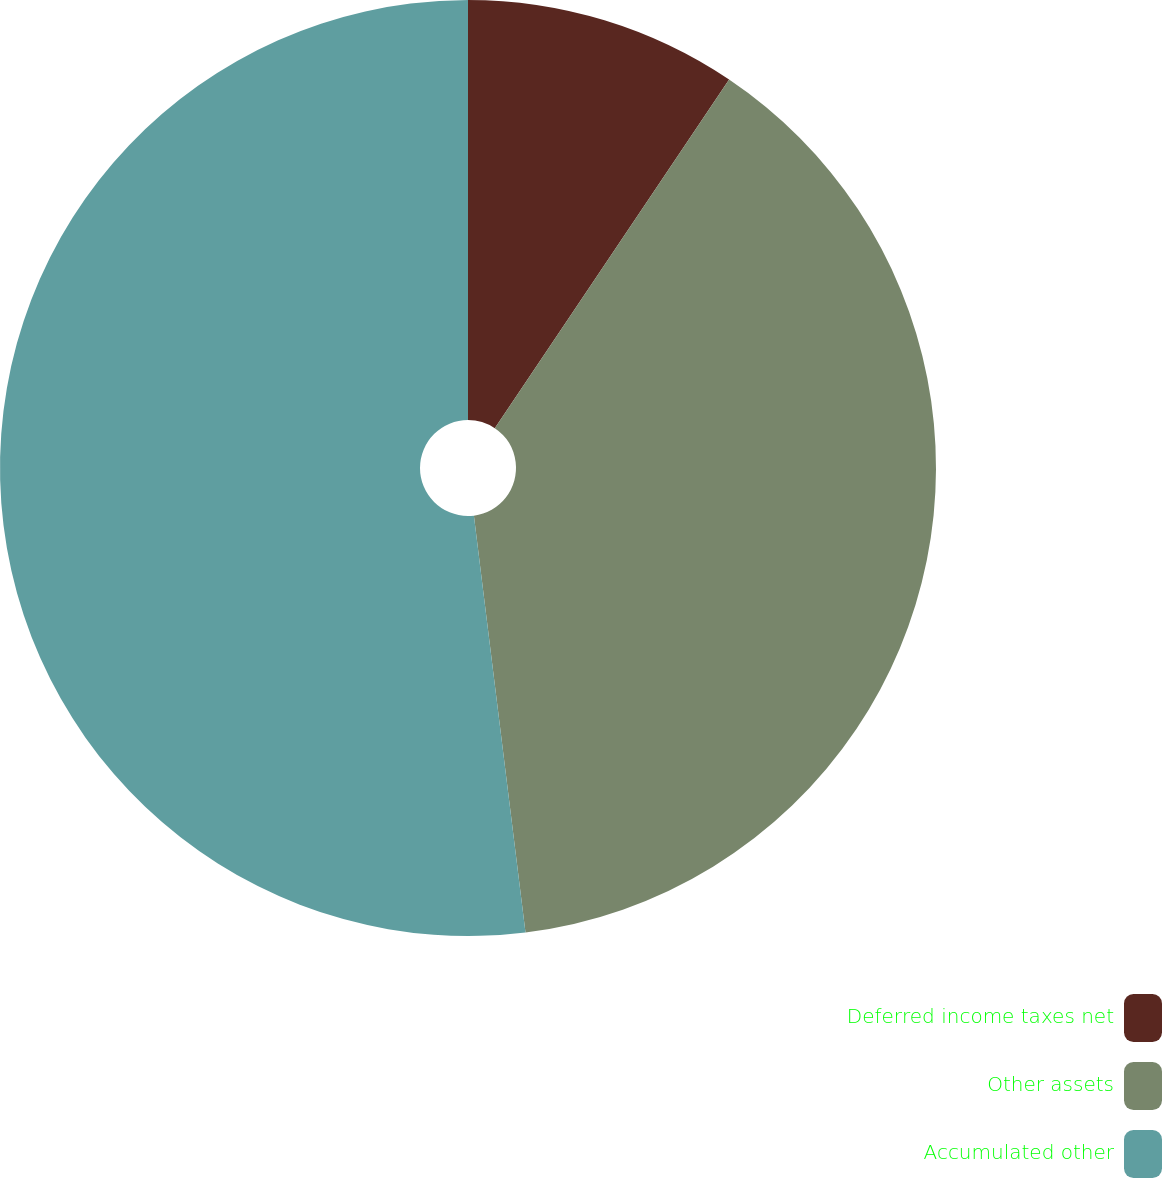Convert chart to OTSL. <chart><loc_0><loc_0><loc_500><loc_500><pie_chart><fcel>Deferred income taxes net<fcel>Other assets<fcel>Accumulated other<nl><fcel>9.42%<fcel>38.62%<fcel>51.96%<nl></chart> 